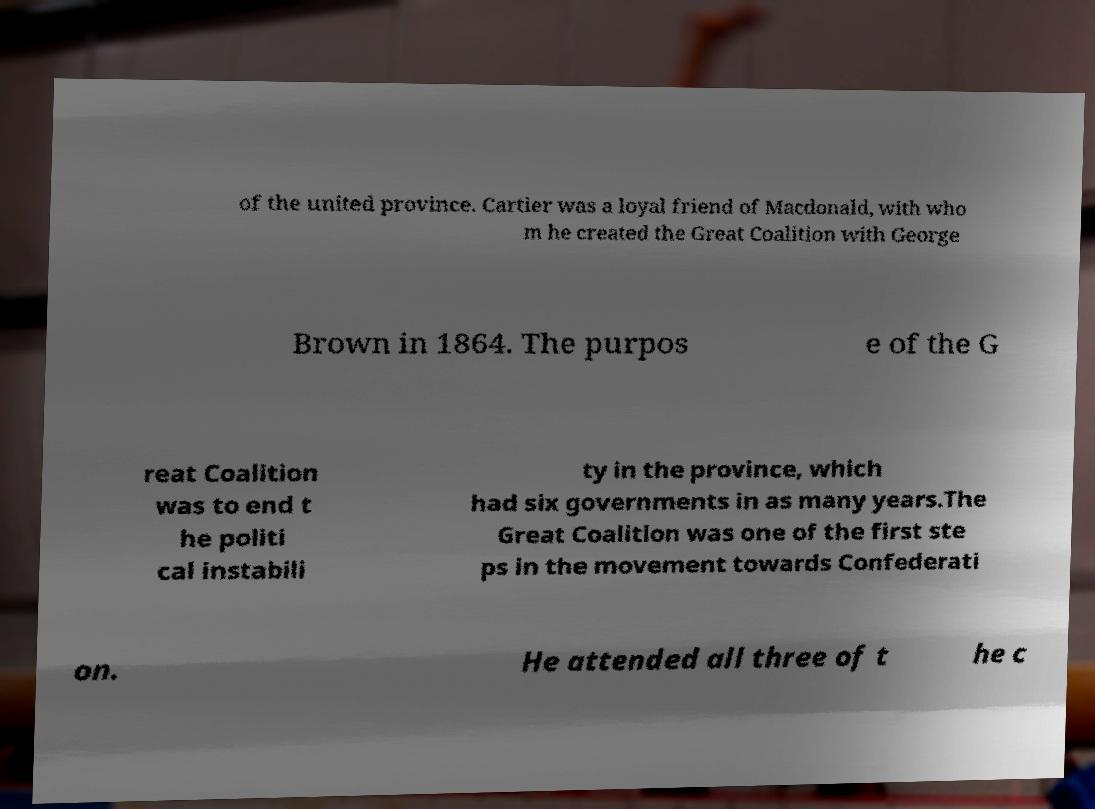Can you read and provide the text displayed in the image?This photo seems to have some interesting text. Can you extract and type it out for me? of the united province. Cartier was a loyal friend of Macdonald, with who m he created the Great Coalition with George Brown in 1864. The purpos e of the G reat Coalition was to end t he politi cal instabili ty in the province, which had six governments in as many years.The Great Coalition was one of the first ste ps in the movement towards Confederati on. He attended all three of t he c 